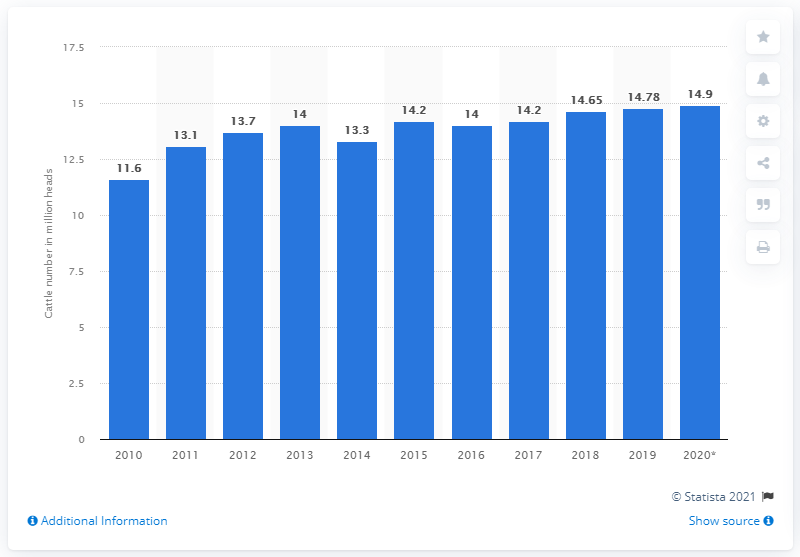Specify some key components in this picture. In the year before, there were 14.9 million head of cattle in Argentina. It is estimated that there were approximately 14.9 million head of cattle in Argentina in 2020. 